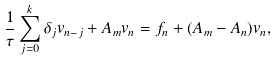Convert formula to latex. <formula><loc_0><loc_0><loc_500><loc_500>\frac { 1 } { \tau } \sum _ { j = 0 } ^ { k } \delta _ { j } v _ { n - j } + A _ { m } v _ { n } = f _ { n } + ( A _ { m } - A _ { n } ) v _ { n } ,</formula> 